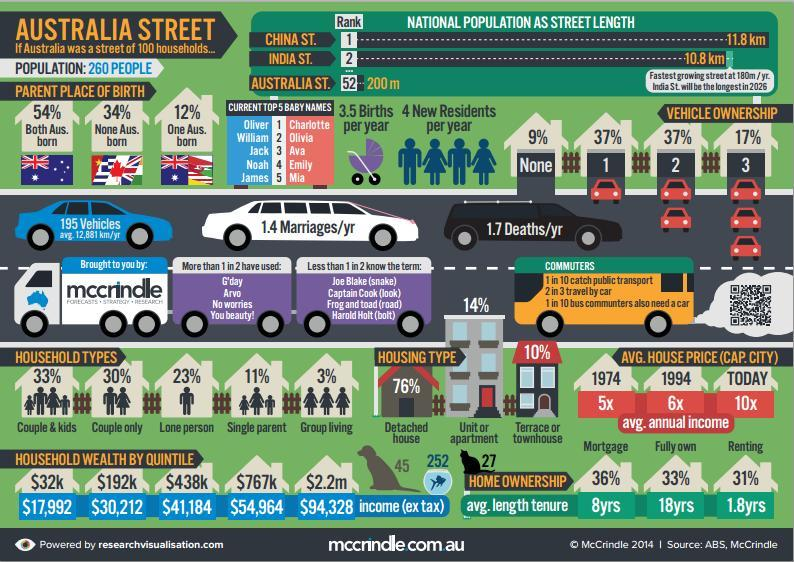What percentage of household have Couple and kids?
Answer the question with a short phrase. 33% What is the third name in the top 5 for boys? Jack What percentage of people own 1 vehicle? 37% What percentage of houses are Terrace or townhouse? 10% What percentage fully own their homes? 33% What percentage of people own no vehicles? 9% What percentage of household have couple only? 30% What is the avg. length tenure for people who rent their house? 1.8yrs What percentage of houses are Detached? 76% What is the avg. length tenure for people who have mortgage on their house? 8yrs What is the total number of pets owned by the households? 324 What percentage of household have Group living? 3% What is the percentage of household where both parents are Australian born? 54% What percentage of people own 3 vehicles? 17% What percentage of houses are unit or apartment? 14% What is the avg. length tenure for people who fully own their house? 18 yrs What is the Fourth name in the top 5 for boys? Noah What percentage of household have one Australian born parent? 12% What is the Fourth name in the top 5 for girls? Emily What is the third name in the top 5 for girls? Ava 